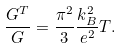Convert formula to latex. <formula><loc_0><loc_0><loc_500><loc_500>\frac { G ^ { T } } { G } = \frac { \pi ^ { 2 } } { 3 } \frac { k _ { B } ^ { 2 } } { e ^ { 2 } } T .</formula> 